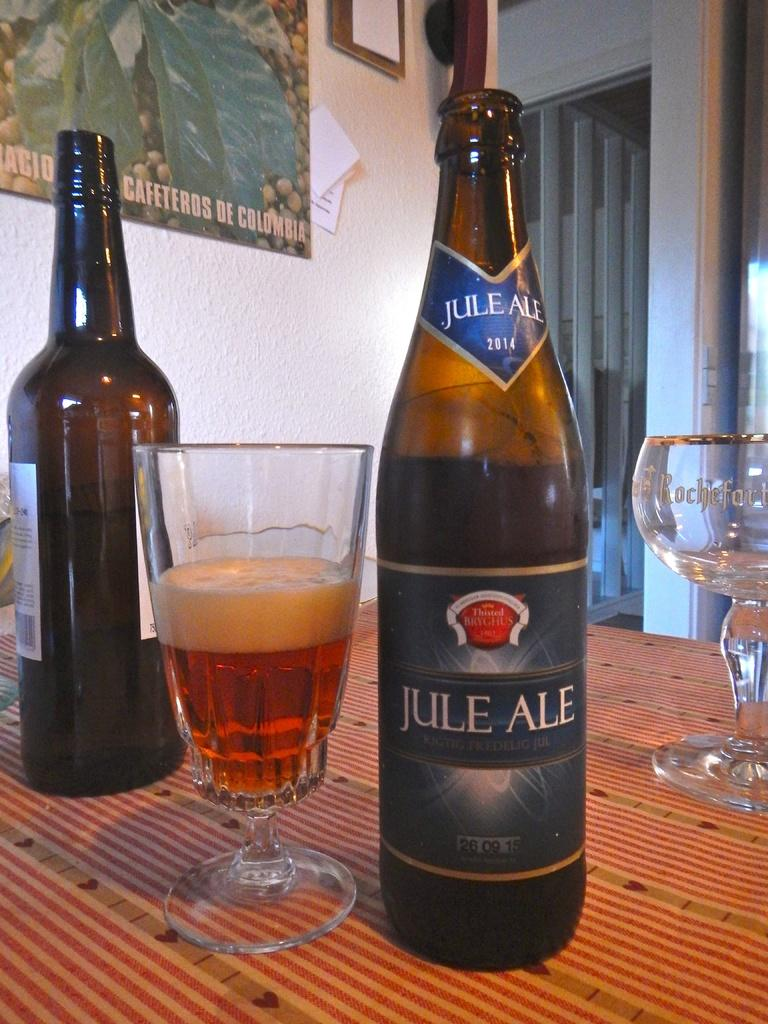What is present on the table in the image? There is a bottle and a glass with a drink in it on the table. What can be seen in the background of the image? There is a wall, a frame, and a paper in the background of the image. What is the purpose of the bottle and glass in the image? The bottle and glass are likely used for holding and consuming a beverage. Can you describe the river flowing in the background of the image? There is no river present in the image; the background features a wall, a frame, and a paper. 